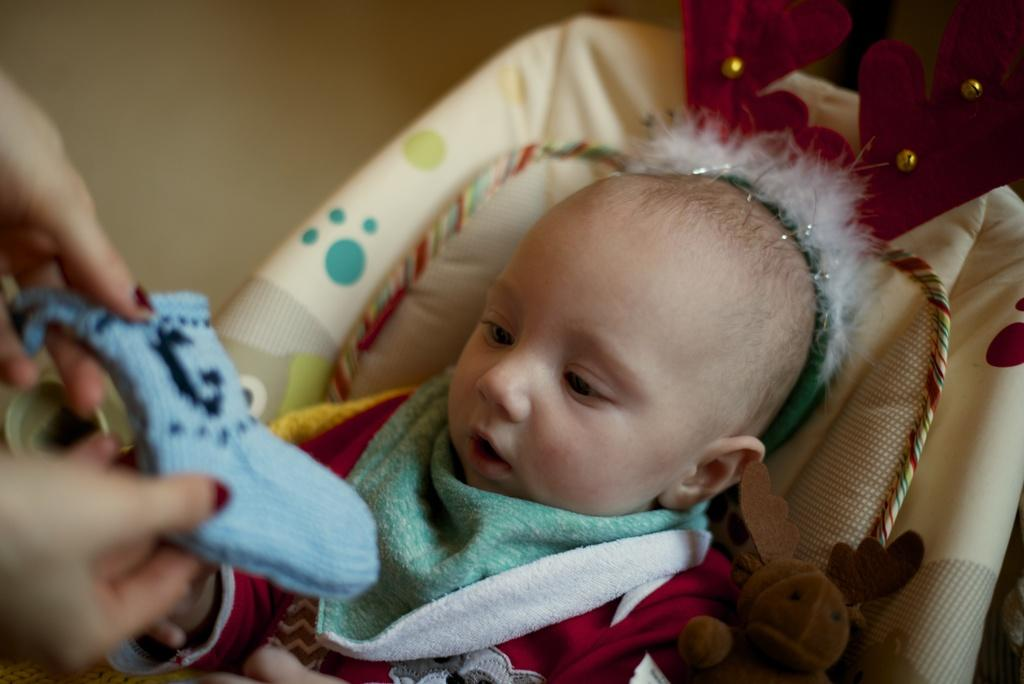What is the main subject of the image? There is a baby in the image. Where is the baby positioned in the image? The baby is lying on a small bed. What can be seen in the hands of the person holding the baby? There are hands holding a blue sock in the image. What is the blue sock doing in the image? The blue sock is on the baby. What type of company is providing maid services in the image? There is no mention of a company or maid services in the image; it features a baby lying on a small bed with a blue sock on them. 